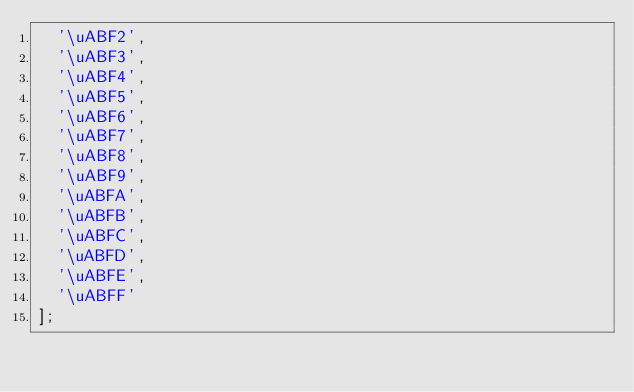Convert code to text. <code><loc_0><loc_0><loc_500><loc_500><_JavaScript_>	'\uABF2',
	'\uABF3',
	'\uABF4',
	'\uABF5',
	'\uABF6',
	'\uABF7',
	'\uABF8',
	'\uABF9',
	'\uABFA',
	'\uABFB',
	'\uABFC',
	'\uABFD',
	'\uABFE',
	'\uABFF'
];</code> 